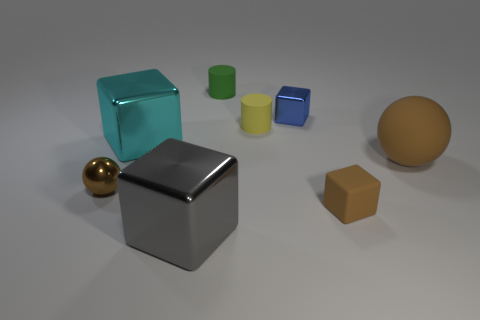Subtract 1 blocks. How many blocks are left? 3 Subtract all cyan blocks. How many blocks are left? 3 Subtract all rubber blocks. How many blocks are left? 3 Subtract all red blocks. Subtract all blue cylinders. How many blocks are left? 4 Add 2 small matte things. How many objects exist? 10 Subtract all cylinders. How many objects are left? 6 Add 5 small brown cubes. How many small brown cubes exist? 6 Subtract 1 gray cubes. How many objects are left? 7 Subtract all tiny blue metallic objects. Subtract all cyan objects. How many objects are left? 6 Add 4 big cyan metallic blocks. How many big cyan metallic blocks are left? 5 